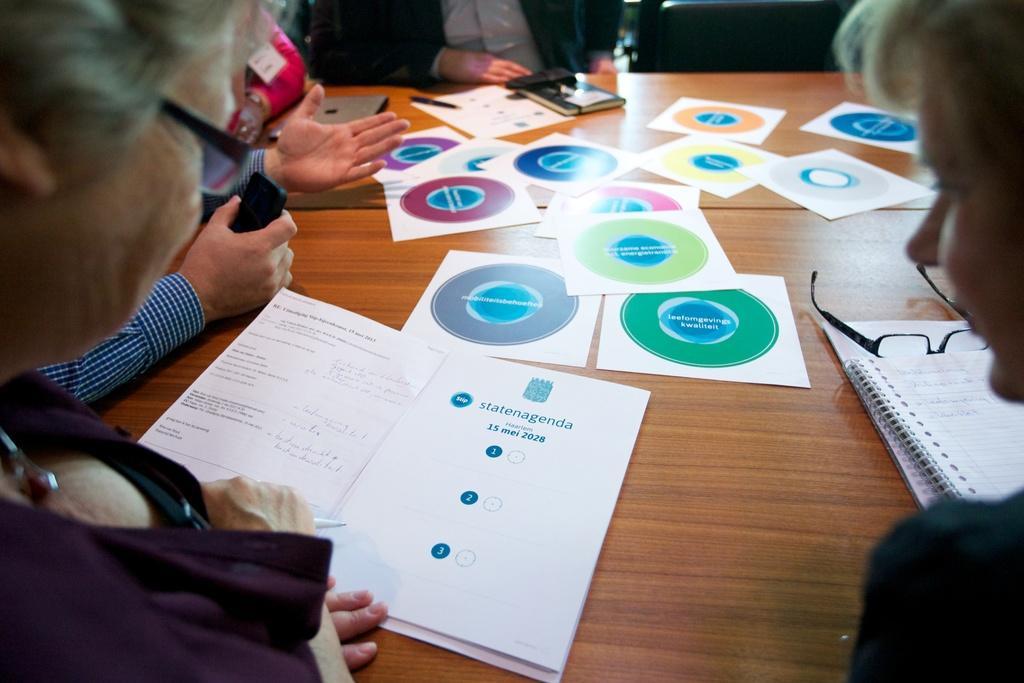How would you summarize this image in a sentence or two? In this image there is a table and we can see people sitting around the table. We can see books, papers, glasses and tabs placed on the table. 